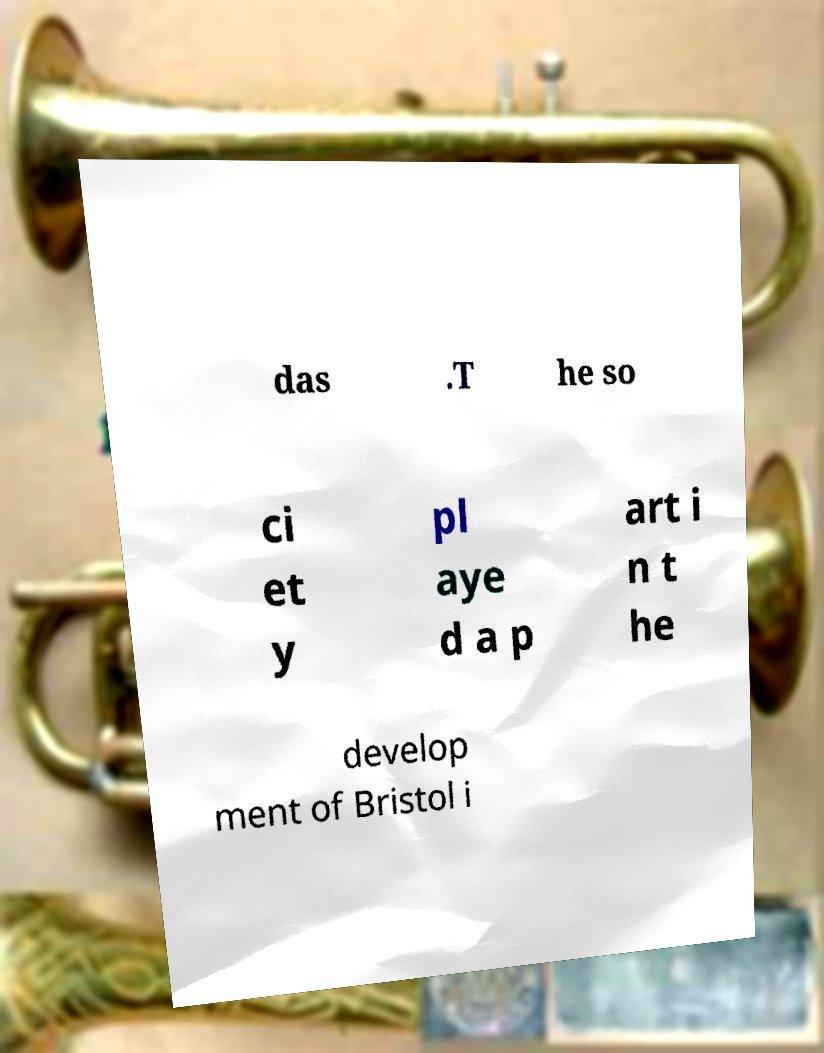Could you extract and type out the text from this image? das .T he so ci et y pl aye d a p art i n t he develop ment of Bristol i 